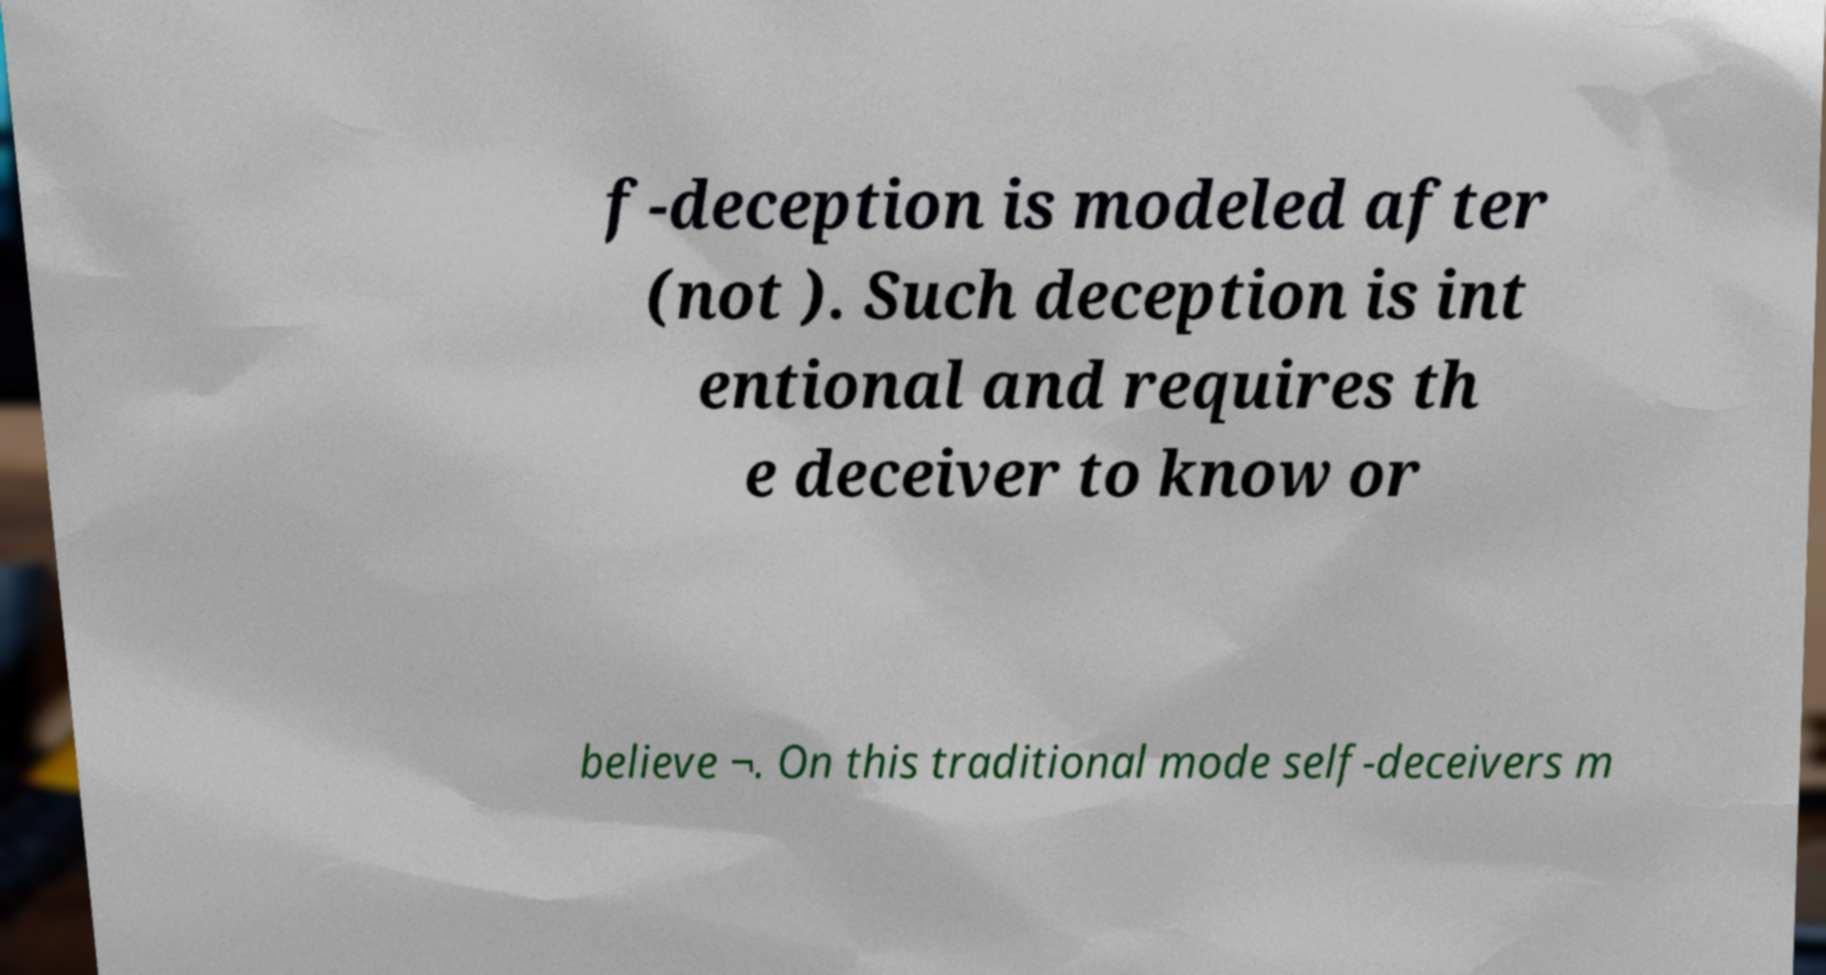Can you read and provide the text displayed in the image?This photo seems to have some interesting text. Can you extract and type it out for me? f-deception is modeled after (not ). Such deception is int entional and requires th e deceiver to know or believe ¬. On this traditional mode self-deceivers m 